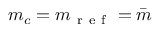Convert formula to latex. <formula><loc_0><loc_0><loc_500><loc_500>m _ { c } = m _ { r e f } = \bar { m }</formula> 